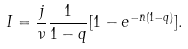<formula> <loc_0><loc_0><loc_500><loc_500>I = \frac { j } { \nu } \frac { 1 } { 1 - q } [ 1 - e ^ { - \bar { n } ( 1 - q ) } ] .</formula> 